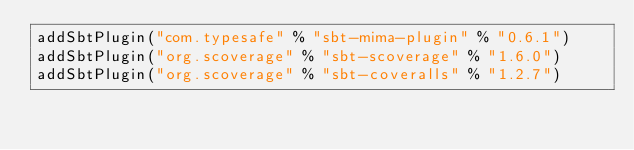<code> <loc_0><loc_0><loc_500><loc_500><_Scala_>addSbtPlugin("com.typesafe" % "sbt-mima-plugin" % "0.6.1")
addSbtPlugin("org.scoverage" % "sbt-scoverage" % "1.6.0")
addSbtPlugin("org.scoverage" % "sbt-coveralls" % "1.2.7")
</code> 